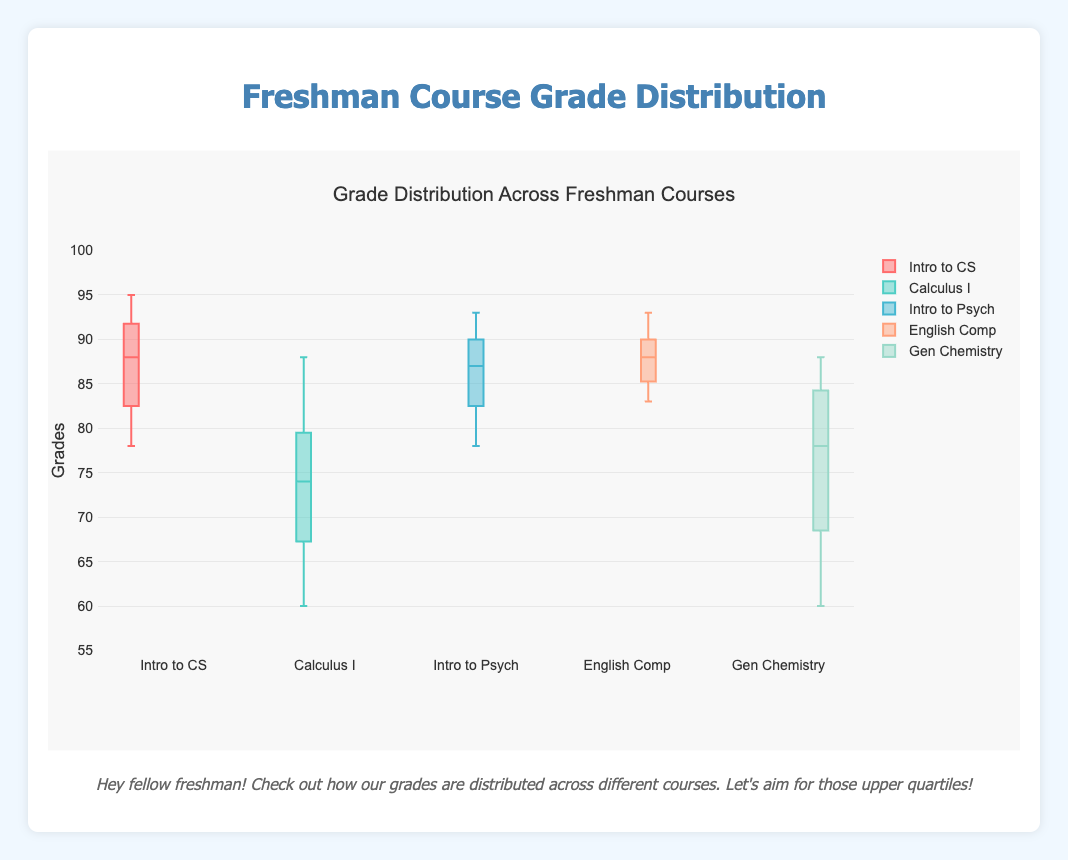What are the courses displayed in the box plot? The courses listed in the box plot can be identified by looking at the names of each box plot.
Answer: Introduction to Computer Science, Calculus I, Introduction to Psychology, English Composition, General Chemistry What is the title of the box plot? The title is usually displayed at the top of the plot.
Answer: Grade Distribution Across Freshman Courses Which course has the highest median grade? To find the course with the highest median grade, locate the line inside the box (the median) and compare across all courses.
Answer: Introduction to Computer Science What is the lowest grade in the Calculus I course? Look at the bottom whisker of the Calculus I box plot to find the minimum value.
Answer: 60 Which two courses have the most similar median grades? Compare the median lines (inside the boxes) of all the courses to find the two that are closest.
Answer: English Composition and Introduction to Psychology What is the range of grades for the General Chemistry course? The range is the difference between the highest and lowest values, indicated by the top and bottom whiskers of the General Chemistry box plot.
Answer: 88 - 60 = 28 Between which grades do the interquartile ranges (IQR) for Introduction to Psychology fall? The IQR is the range between the first quartile (bottom of the box) and the third quartile (top of the box) of the Introduction to Psychology box plot.
Answer: 82 to 91 How many outliers are there in the English Composition course data? Outliers are typically represented by dots outside the whiskers. Count these dots.
Answer: 0 Which course shows the smallest variability in student grades? The course with the smallest box (interquartile range) indicates the least variability.
Answer: English Composition What are the first and third quartiles for Introduction to Computer Science? The first quartile is the bottom of the box and the third quartile is the top of the box for the Introduction to Computer Science box plot.
Answer: First quartile: 84, Third quartile: 92 